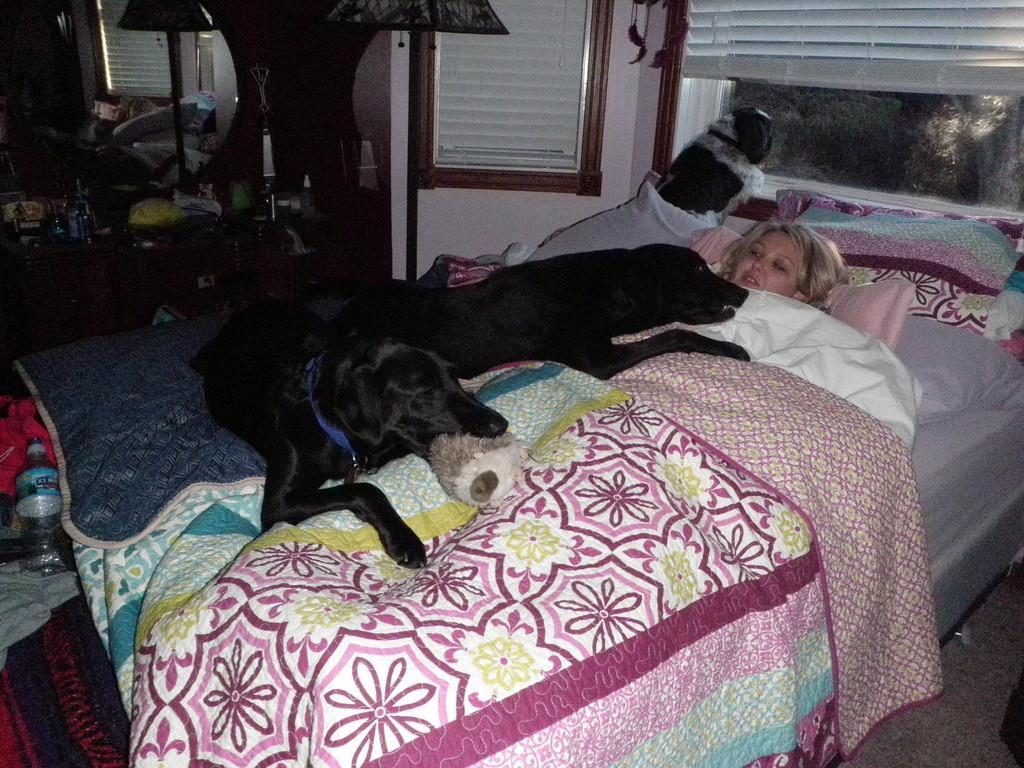Please provide a concise description of this image. As we can see in the image there is a lamp, window and a bed. On bed there are pillows, a woman lying and three dogs. 